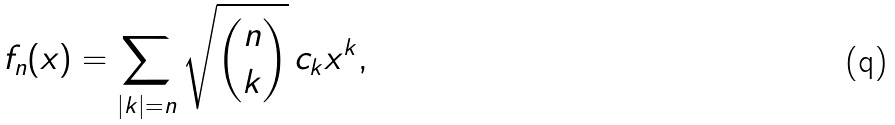<formula> <loc_0><loc_0><loc_500><loc_500>f _ { n } ( x ) = \sum _ { | k | = n } \sqrt { \binom { n } { k } } \, c _ { k } x ^ { k } ,</formula> 